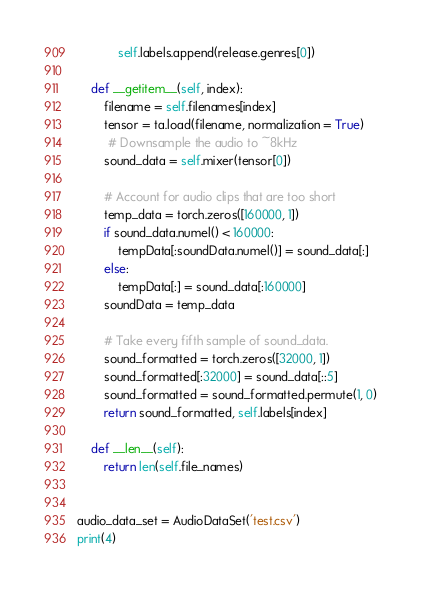Convert code to text. <code><loc_0><loc_0><loc_500><loc_500><_Python_>            self.labels.append(release.genres[0])

    def __getitem__(self, index):
        filename = self.filenames[index]
        tensor = ta.load(filename, normalization = True)
         # Downsample the audio to ~8kHz
        sound_data = self.mixer(tensor[0])

        # Account for audio clips that are too short
        temp_data = torch.zeros([160000, 1])
        if sound_data.numel() < 160000:
            tempData[:soundData.numel()] = sound_data[:]
        else:
            tempData[:] = sound_data[:160000]
        soundData = temp_data

        # Take every fifth sample of sound_data.
        sound_formatted = torch.zeros([32000, 1])
        sound_formatted[:32000] = sound_data[::5] 
        sound_formatted = sound_formatted.permute(1, 0)
        return sound_formatted, self.labels[index]

    def __len__(self):
        return len(self.file_names)


audio_data_set = AudioDataSet('test.csv')
print(4)</code> 